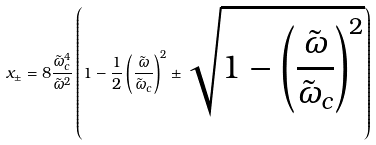Convert formula to latex. <formula><loc_0><loc_0><loc_500><loc_500>x _ { \pm } = 8 \frac { \tilde { \omega } _ { c } ^ { 4 } } { \tilde { \omega } ^ { 2 } } \left ( 1 - \frac { 1 } { 2 } \left ( \frac { \tilde { \omega } } { \tilde { \omega } _ { c } } \right ) ^ { 2 } \pm \sqrt { 1 - \left ( \frac { \tilde { \omega } } { \tilde { \omega } _ { c } } \right ) ^ { 2 } } \right )</formula> 